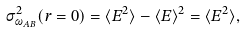Convert formula to latex. <formula><loc_0><loc_0><loc_500><loc_500>\sigma ^ { 2 } _ { \omega _ { A B } } ( r = 0 ) = \langle E ^ { 2 } \rangle - \langle E \rangle ^ { 2 } = \langle E ^ { 2 } \rangle ,</formula> 